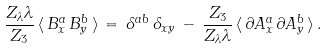Convert formula to latex. <formula><loc_0><loc_0><loc_500><loc_500>\frac { Z _ { \lambda } \lambda } { Z _ { 3 } } \, \langle \, B ^ { a } _ { x } \, B ^ { b } _ { y } \, \rangle \, = \, \delta ^ { a b } \, \delta _ { x y } \, - \, \frac { Z _ { 3 } } { Z _ { \lambda } \lambda } \, \langle \, \partial A ^ { a } _ { x } \, \partial A ^ { b } _ { y } \, \rangle \, .</formula> 